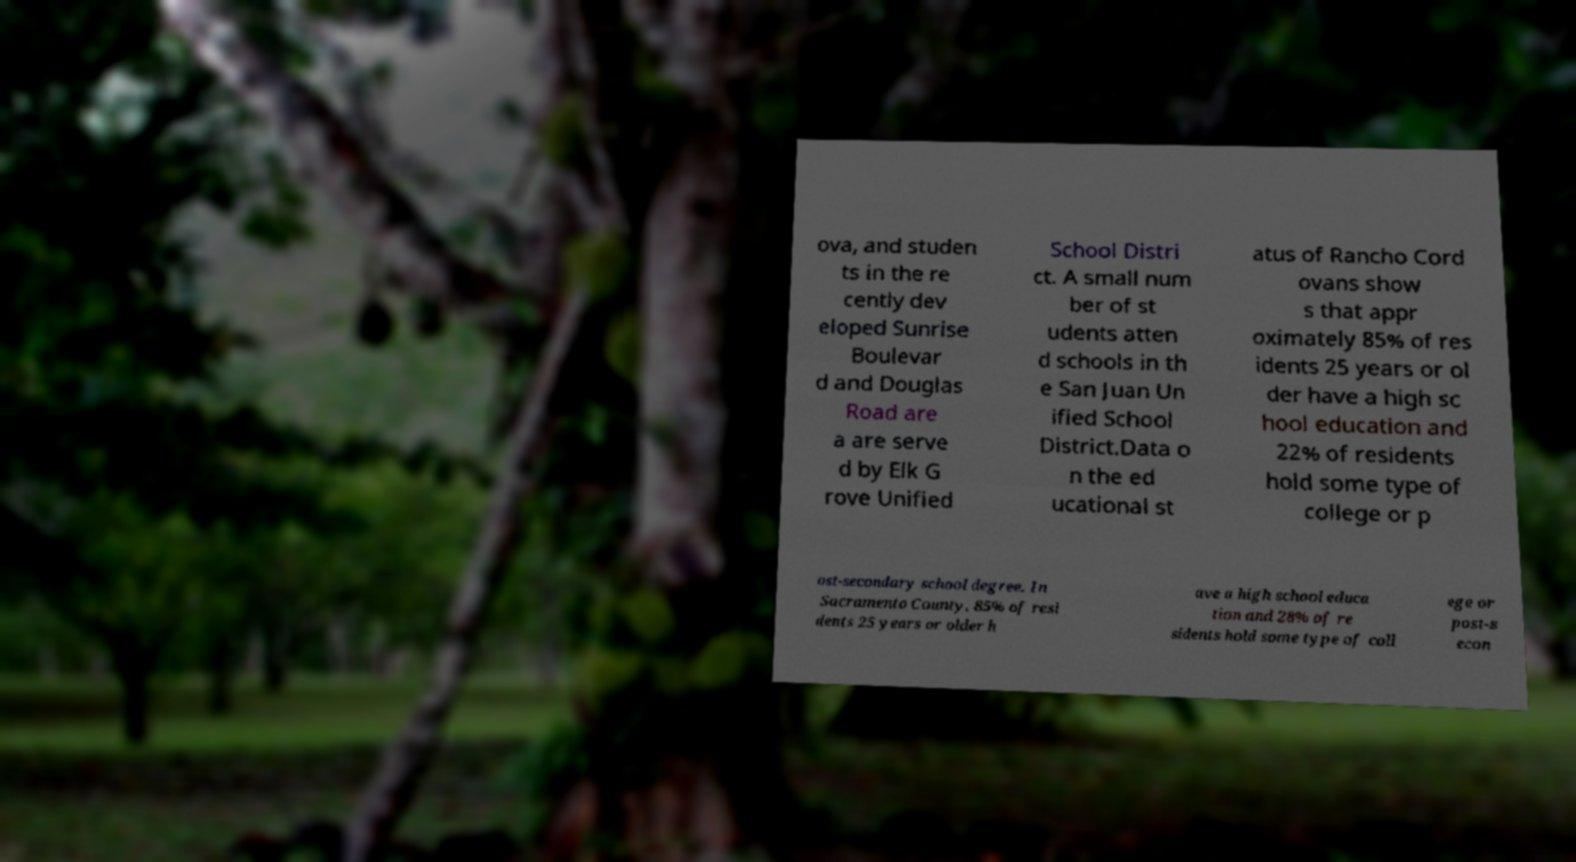Please identify and transcribe the text found in this image. ova, and studen ts in the re cently dev eloped Sunrise Boulevar d and Douglas Road are a are serve d by Elk G rove Unified School Distri ct. A small num ber of st udents atten d schools in th e San Juan Un ified School District.Data o n the ed ucational st atus of Rancho Cord ovans show s that appr oximately 85% of res idents 25 years or ol der have a high sc hool education and 22% of residents hold some type of college or p ost-secondary school degree. In Sacramento County, 85% of resi dents 25 years or older h ave a high school educa tion and 28% of re sidents hold some type of coll ege or post-s econ 